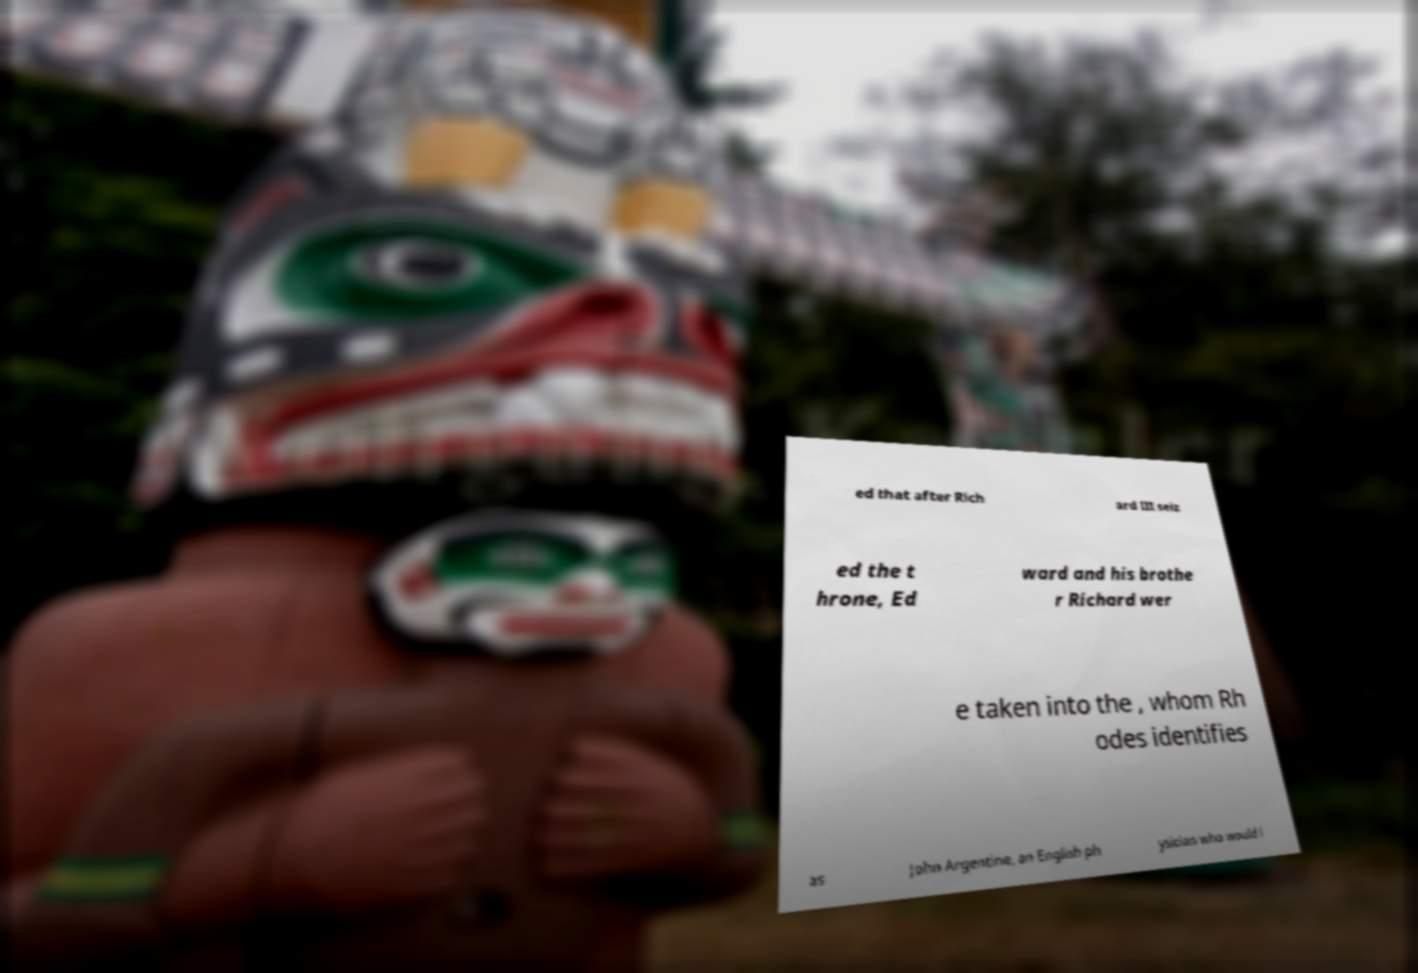Please read and relay the text visible in this image. What does it say? ed that after Rich ard III seiz ed the t hrone, Ed ward and his brothe r Richard wer e taken into the , whom Rh odes identifies as John Argentine, an English ph ysician who would l 